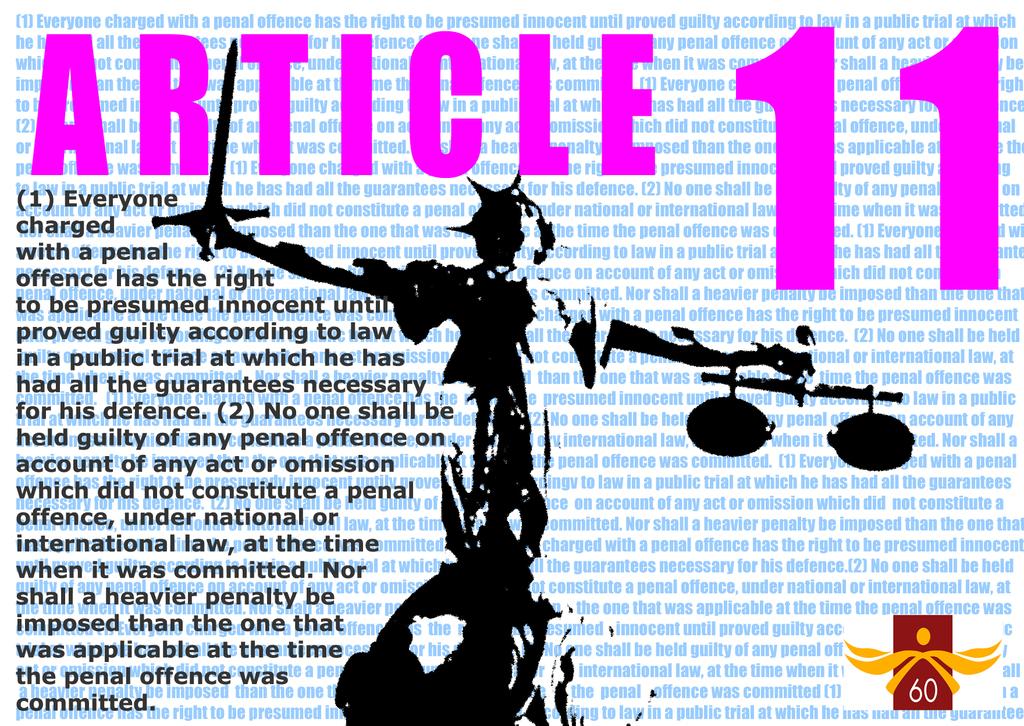What number article is being discussed?
Your response must be concise. 11. What is this article?
Ensure brevity in your answer.  11. 